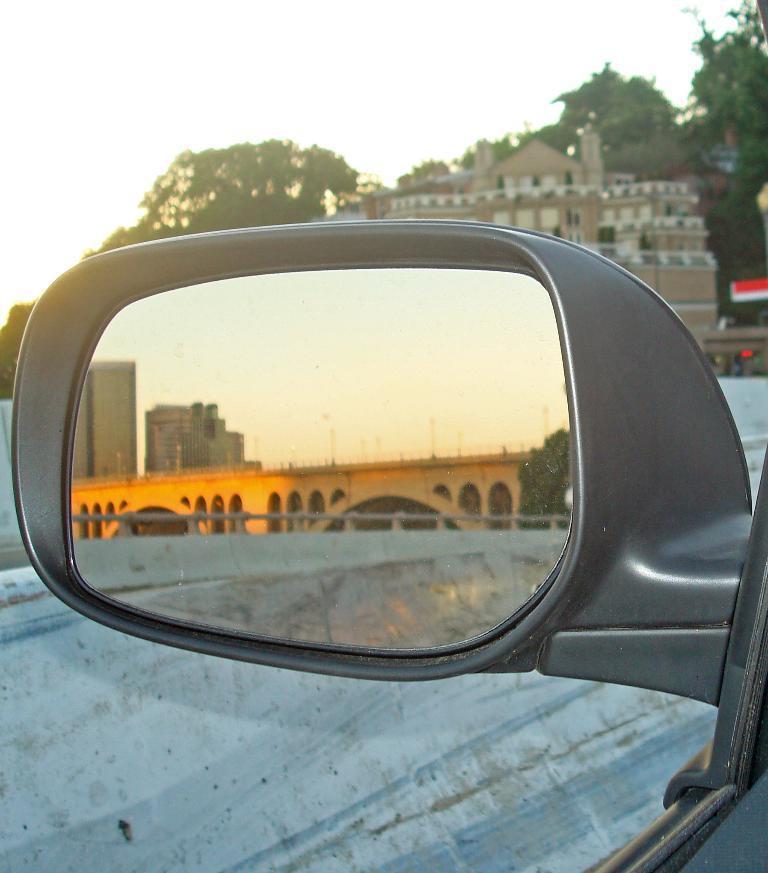Could you give a brief overview of what you see in this image? In the foreground of the image we can see a car side mirror. In the mirror we can see a bridge ,couple of buildings ,tree. In the background we can see a building group of buildings and sky. 